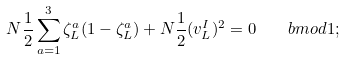Convert formula to latex. <formula><loc_0><loc_0><loc_500><loc_500>N \frac { 1 } { 2 } \sum _ { a = 1 } ^ { 3 } \zeta _ { L } ^ { a } ( 1 - \zeta _ { L } ^ { a } ) + N \frac { 1 } { 2 } ( v _ { L } ^ { I } ) ^ { 2 } = 0 \ \ \ b m o d 1 ;</formula> 